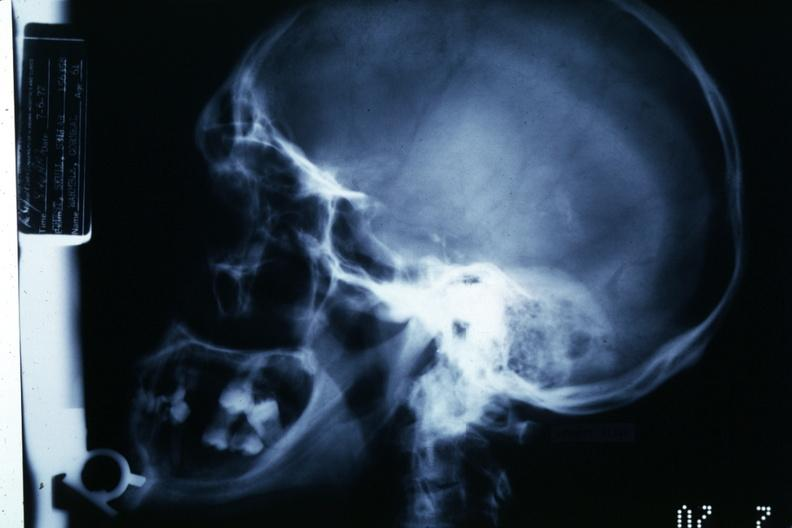does squamous cell carcinoma, lip remote, show x-ray showing large sella turcica?
Answer the question using a single word or phrase. No 